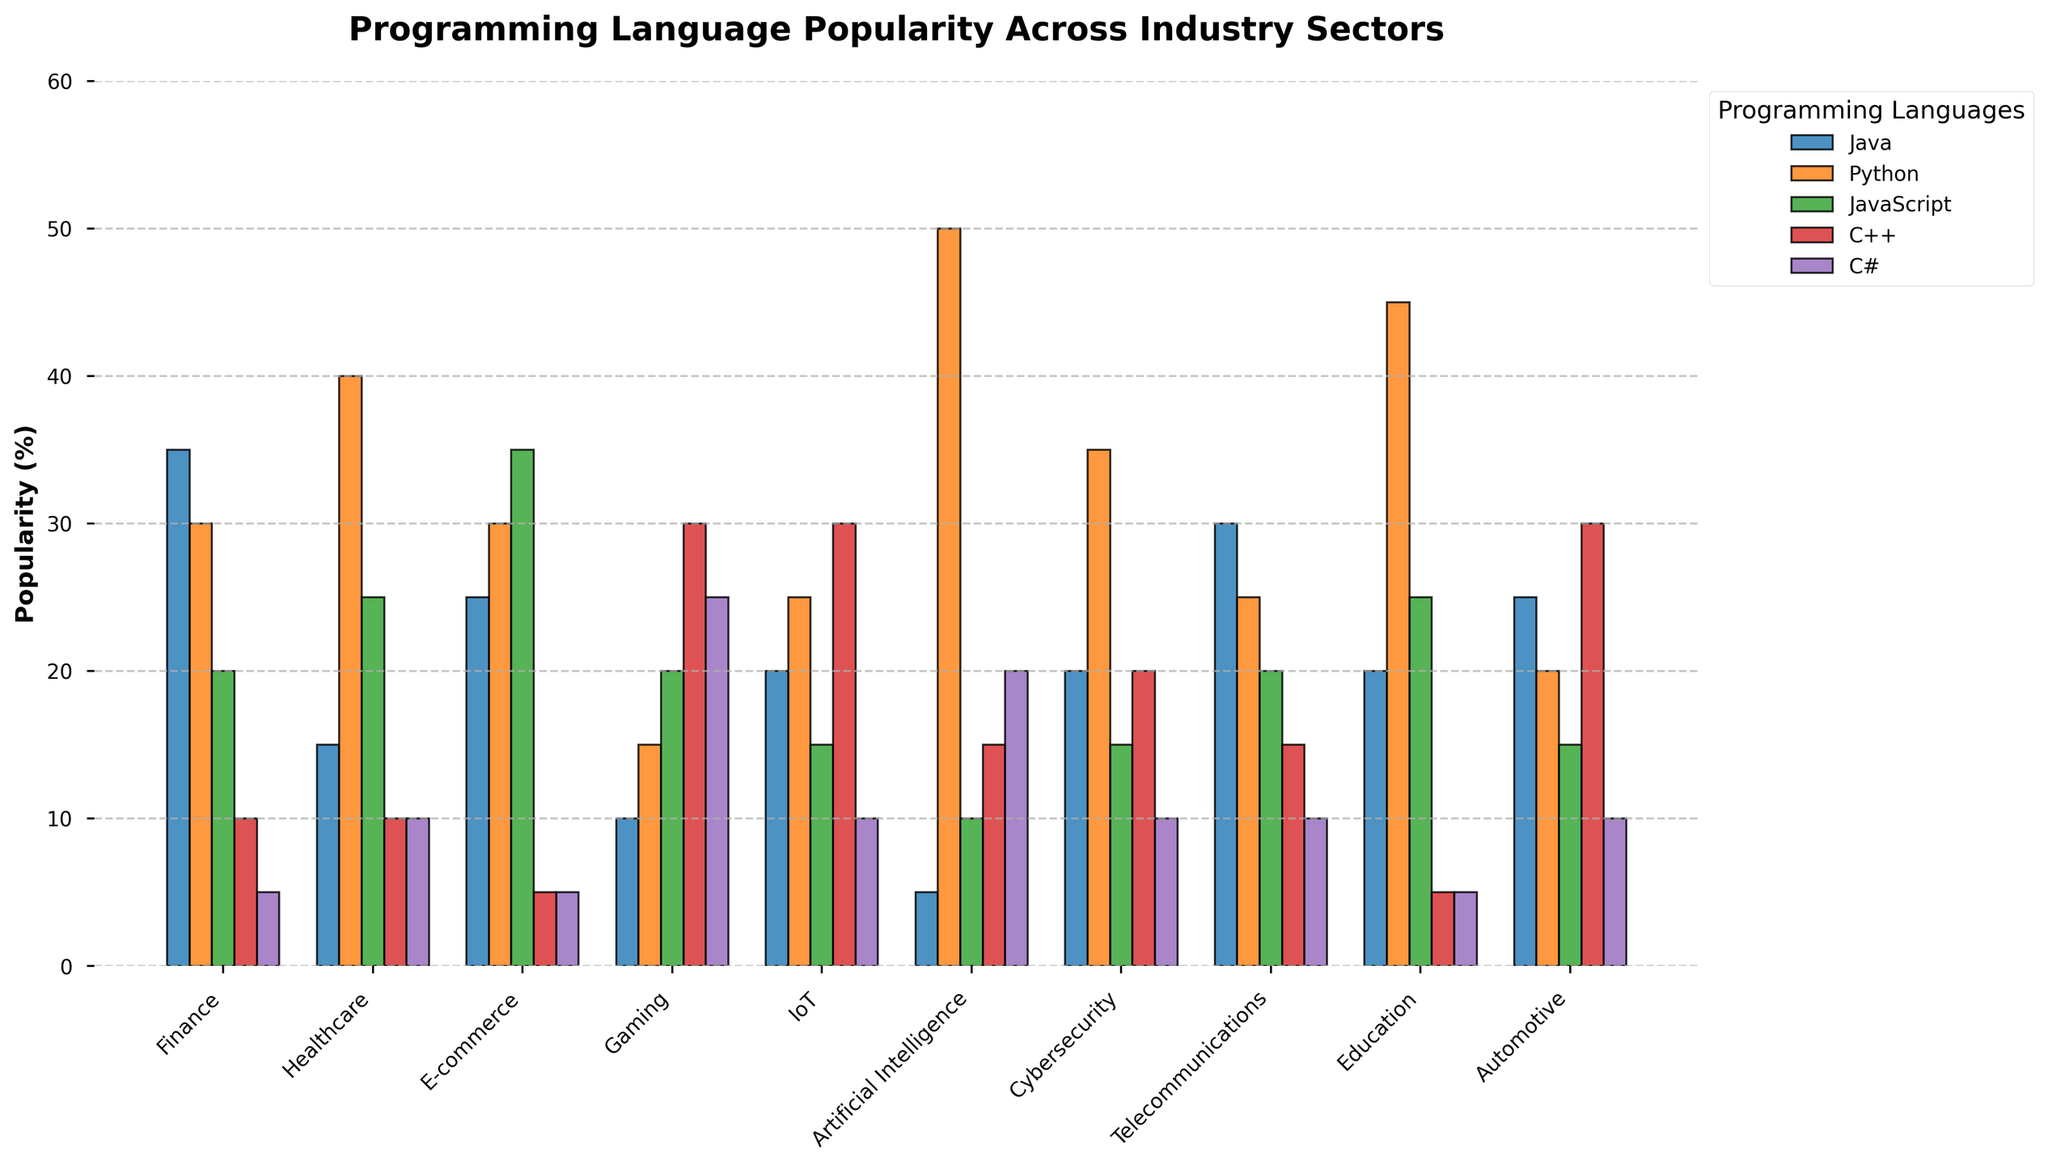Which industry sector shows the highest popularity for Python? Artificial Intelligence shows the highest popularity for Python with 50%. This can be observed by looking at the height of the Python bars across all industry sectors and noting that the Artificial Intelligence bar is tallest.
Answer: Artificial Intelligence Which programming language is most popular in the Finance sector? Java is the most popular programming language in the Finance sector with a popularity of 35%. This can be deduced by comparing the heights of the bars for each programming language within the Finance sector. The Java bar is the tallest.
Answer: Java In which industry sector is C++ as popular as C#? C++ and C# both have a popularity of 10% in the IoT sector. You can observe this by seeing the heights of the C++ and C# bars being equal in the IoT sector.
Answer: IoT Which sector has the smallest difference in popularity between Java and JavaScript? The Healthcare sector has the smallest difference between Java (15%) and JavaScript (25%) with a difference of 10 percentage points. This is found by calculating the differences for all sectors and identifying the smallest one.
Answer: Healthcare Which industry has the greatest range of popularity percentages for the different programming languages? Artificial Intelligence has the greatest range of popularity percentages (50% for Python and 5% for JavaScript), giving a range of 45 percentage points. This is calculated by finding the difference between the maximum and minimum popularity values in each sector.
Answer: Artificial Intelligence What is the average popularity of C# across the sectors? To find the average popularity of C#, sum the values (5+10+5+25+10+20+10+10+5+10 = 110) and divide by the number of sectors (10). The average is 110/10 = 11%.
Answer: 11% Which language has the most consistent popularity across all sectors? C# appears to be the most consistent with values ranging from 5% to 25%. This is determined by analyzing the range of popularity percentages for each language across all sectors.
Answer: C# How does the popularity of C++ in the Gaming sector compare to its popularity in the Finance sector? The popularity of C++ in Gaming is 30%, whereas in Finance it is 10%. This highlights that C++ is significantly more popular in Gaming than in Finance.
Answer: C++ is more popular in Gaming Which industry has the highest combined popularity for JavaScript and Python? The combined popularity for JavaScript and Python is highest in Artificial Intelligence, with 10% for JavaScript and 50% for Python, totalling 60%. This can be determined by adding the values for JavaScript and Python in each sector and comparing the totals.
Answer: Artificial Intelligence Is Python more popular than Java in the Education sector? Yes, Python is more popular than Java in the Education sector, with 45% compared to Java's 20%. This is observed by comparing the heights of the Python and Java bars in the Education sector.
Answer: Yes 